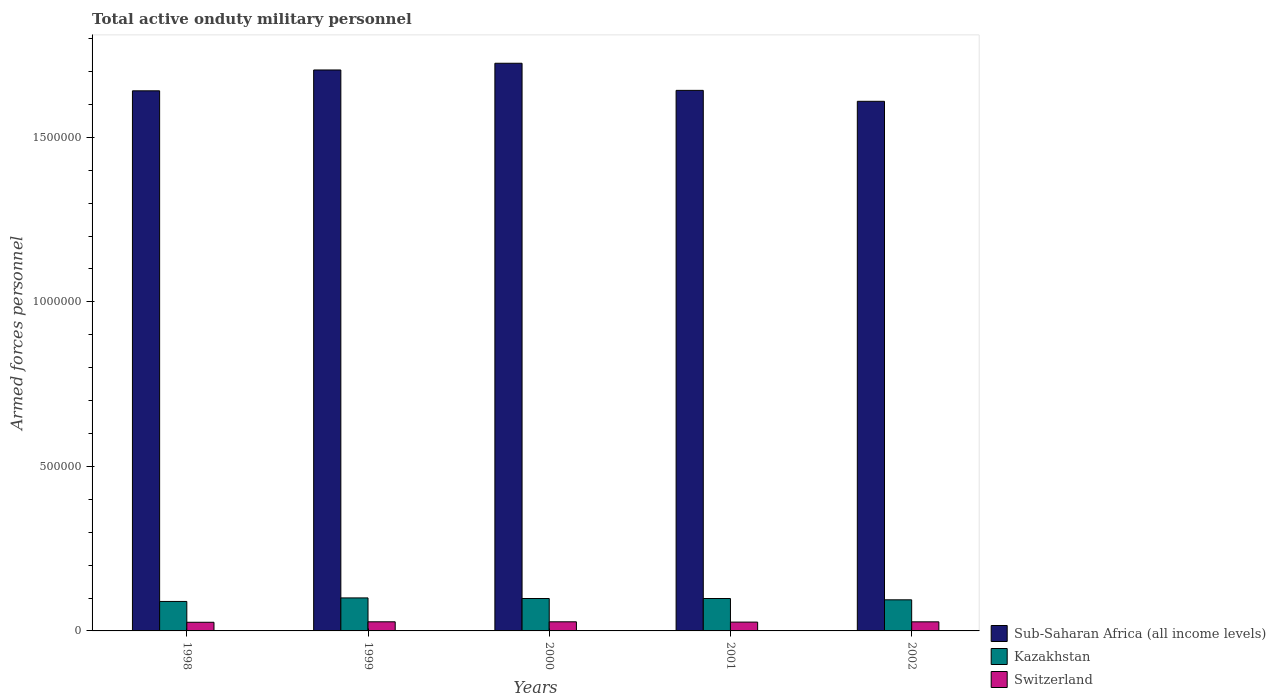How many different coloured bars are there?
Make the answer very short. 3. How many groups of bars are there?
Provide a short and direct response. 5. Are the number of bars on each tick of the X-axis equal?
Offer a very short reply. Yes. What is the label of the 2nd group of bars from the left?
Your answer should be very brief. 1999. In how many cases, is the number of bars for a given year not equal to the number of legend labels?
Ensure brevity in your answer.  0. What is the number of armed forces personnel in Kazakhstan in 1999?
Your answer should be very brief. 1.00e+05. Across all years, what is the maximum number of armed forces personnel in Kazakhstan?
Ensure brevity in your answer.  1.00e+05. Across all years, what is the minimum number of armed forces personnel in Switzerland?
Provide a succinct answer. 2.63e+04. What is the total number of armed forces personnel in Switzerland in the graph?
Offer a very short reply. 1.36e+05. What is the difference between the number of armed forces personnel in Sub-Saharan Africa (all income levels) in 1998 and that in 2001?
Offer a terse response. -1350. What is the difference between the number of armed forces personnel in Kazakhstan in 1998 and the number of armed forces personnel in Switzerland in 2002?
Offer a very short reply. 6.20e+04. What is the average number of armed forces personnel in Switzerland per year?
Provide a succinct answer. 2.72e+04. In the year 1998, what is the difference between the number of armed forces personnel in Sub-Saharan Africa (all income levels) and number of armed forces personnel in Switzerland?
Offer a very short reply. 1.62e+06. In how many years, is the number of armed forces personnel in Sub-Saharan Africa (all income levels) greater than 400000?
Your answer should be very brief. 5. What is the ratio of the number of armed forces personnel in Switzerland in 1999 to that in 2000?
Keep it short and to the point. 1. Is the number of armed forces personnel in Kazakhstan in 2000 less than that in 2002?
Keep it short and to the point. No. What is the difference between the highest and the second highest number of armed forces personnel in Sub-Saharan Africa (all income levels)?
Keep it short and to the point. 2.04e+04. What is the difference between the highest and the lowest number of armed forces personnel in Kazakhstan?
Keep it short and to the point. 1.07e+04. What does the 3rd bar from the left in 1998 represents?
Your response must be concise. Switzerland. What does the 3rd bar from the right in 2001 represents?
Your response must be concise. Sub-Saharan Africa (all income levels). Are all the bars in the graph horizontal?
Keep it short and to the point. No. How many years are there in the graph?
Ensure brevity in your answer.  5. What is the difference between two consecutive major ticks on the Y-axis?
Provide a short and direct response. 5.00e+05. Are the values on the major ticks of Y-axis written in scientific E-notation?
Make the answer very short. No. Does the graph contain any zero values?
Provide a succinct answer. No. Where does the legend appear in the graph?
Offer a very short reply. Bottom right. How many legend labels are there?
Keep it short and to the point. 3. What is the title of the graph?
Keep it short and to the point. Total active onduty military personnel. What is the label or title of the Y-axis?
Give a very brief answer. Armed forces personnel. What is the Armed forces personnel in Sub-Saharan Africa (all income levels) in 1998?
Make the answer very short. 1.64e+06. What is the Armed forces personnel of Kazakhstan in 1998?
Your answer should be very brief. 8.96e+04. What is the Armed forces personnel of Switzerland in 1998?
Keep it short and to the point. 2.63e+04. What is the Armed forces personnel of Sub-Saharan Africa (all income levels) in 1999?
Provide a short and direct response. 1.70e+06. What is the Armed forces personnel in Kazakhstan in 1999?
Offer a very short reply. 1.00e+05. What is the Armed forces personnel in Switzerland in 1999?
Offer a terse response. 2.77e+04. What is the Armed forces personnel of Sub-Saharan Africa (all income levels) in 2000?
Your answer should be compact. 1.73e+06. What is the Armed forces personnel in Kazakhstan in 2000?
Your answer should be very brief. 9.85e+04. What is the Armed forces personnel of Switzerland in 2000?
Give a very brief answer. 2.77e+04. What is the Armed forces personnel of Sub-Saharan Africa (all income levels) in 2001?
Provide a succinct answer. 1.64e+06. What is the Armed forces personnel in Kazakhstan in 2001?
Offer a very short reply. 9.85e+04. What is the Armed forces personnel of Switzerland in 2001?
Offer a very short reply. 2.68e+04. What is the Armed forces personnel of Sub-Saharan Africa (all income levels) in 2002?
Provide a succinct answer. 1.61e+06. What is the Armed forces personnel in Kazakhstan in 2002?
Give a very brief answer. 9.45e+04. What is the Armed forces personnel of Switzerland in 2002?
Offer a terse response. 2.76e+04. Across all years, what is the maximum Armed forces personnel of Sub-Saharan Africa (all income levels)?
Offer a terse response. 1.73e+06. Across all years, what is the maximum Armed forces personnel in Kazakhstan?
Offer a terse response. 1.00e+05. Across all years, what is the maximum Armed forces personnel of Switzerland?
Your answer should be compact. 2.77e+04. Across all years, what is the minimum Armed forces personnel in Sub-Saharan Africa (all income levels)?
Provide a short and direct response. 1.61e+06. Across all years, what is the minimum Armed forces personnel of Kazakhstan?
Provide a succinct answer. 8.96e+04. Across all years, what is the minimum Armed forces personnel in Switzerland?
Provide a succinct answer. 2.63e+04. What is the total Armed forces personnel of Sub-Saharan Africa (all income levels) in the graph?
Provide a succinct answer. 8.32e+06. What is the total Armed forces personnel in Kazakhstan in the graph?
Make the answer very short. 4.81e+05. What is the total Armed forces personnel in Switzerland in the graph?
Ensure brevity in your answer.  1.36e+05. What is the difference between the Armed forces personnel of Sub-Saharan Africa (all income levels) in 1998 and that in 1999?
Your answer should be compact. -6.34e+04. What is the difference between the Armed forces personnel of Kazakhstan in 1998 and that in 1999?
Offer a very short reply. -1.07e+04. What is the difference between the Armed forces personnel in Switzerland in 1998 and that in 1999?
Provide a short and direct response. -1400. What is the difference between the Armed forces personnel in Sub-Saharan Africa (all income levels) in 1998 and that in 2000?
Make the answer very short. -8.38e+04. What is the difference between the Armed forces personnel in Kazakhstan in 1998 and that in 2000?
Offer a terse response. -8900. What is the difference between the Armed forces personnel in Switzerland in 1998 and that in 2000?
Your answer should be very brief. -1400. What is the difference between the Armed forces personnel in Sub-Saharan Africa (all income levels) in 1998 and that in 2001?
Make the answer very short. -1350. What is the difference between the Armed forces personnel of Kazakhstan in 1998 and that in 2001?
Offer a very short reply. -8900. What is the difference between the Armed forces personnel in Switzerland in 1998 and that in 2001?
Provide a short and direct response. -500. What is the difference between the Armed forces personnel in Sub-Saharan Africa (all income levels) in 1998 and that in 2002?
Provide a short and direct response. 3.19e+04. What is the difference between the Armed forces personnel of Kazakhstan in 1998 and that in 2002?
Ensure brevity in your answer.  -4900. What is the difference between the Armed forces personnel in Switzerland in 1998 and that in 2002?
Offer a very short reply. -1300. What is the difference between the Armed forces personnel of Sub-Saharan Africa (all income levels) in 1999 and that in 2000?
Offer a very short reply. -2.04e+04. What is the difference between the Armed forces personnel of Kazakhstan in 1999 and that in 2000?
Provide a succinct answer. 1800. What is the difference between the Armed forces personnel of Sub-Saharan Africa (all income levels) in 1999 and that in 2001?
Ensure brevity in your answer.  6.20e+04. What is the difference between the Armed forces personnel of Kazakhstan in 1999 and that in 2001?
Make the answer very short. 1800. What is the difference between the Armed forces personnel of Switzerland in 1999 and that in 2001?
Provide a succinct answer. 900. What is the difference between the Armed forces personnel in Sub-Saharan Africa (all income levels) in 1999 and that in 2002?
Make the answer very short. 9.52e+04. What is the difference between the Armed forces personnel in Kazakhstan in 1999 and that in 2002?
Ensure brevity in your answer.  5800. What is the difference between the Armed forces personnel in Sub-Saharan Africa (all income levels) in 2000 and that in 2001?
Offer a terse response. 8.24e+04. What is the difference between the Armed forces personnel in Kazakhstan in 2000 and that in 2001?
Make the answer very short. 0. What is the difference between the Armed forces personnel of Switzerland in 2000 and that in 2001?
Your answer should be very brief. 900. What is the difference between the Armed forces personnel in Sub-Saharan Africa (all income levels) in 2000 and that in 2002?
Provide a short and direct response. 1.16e+05. What is the difference between the Armed forces personnel in Kazakhstan in 2000 and that in 2002?
Provide a short and direct response. 4000. What is the difference between the Armed forces personnel of Sub-Saharan Africa (all income levels) in 2001 and that in 2002?
Your response must be concise. 3.32e+04. What is the difference between the Armed forces personnel of Kazakhstan in 2001 and that in 2002?
Give a very brief answer. 4000. What is the difference between the Armed forces personnel in Switzerland in 2001 and that in 2002?
Your response must be concise. -800. What is the difference between the Armed forces personnel of Sub-Saharan Africa (all income levels) in 1998 and the Armed forces personnel of Kazakhstan in 1999?
Your response must be concise. 1.54e+06. What is the difference between the Armed forces personnel in Sub-Saharan Africa (all income levels) in 1998 and the Armed forces personnel in Switzerland in 1999?
Offer a very short reply. 1.61e+06. What is the difference between the Armed forces personnel in Kazakhstan in 1998 and the Armed forces personnel in Switzerland in 1999?
Your answer should be very brief. 6.19e+04. What is the difference between the Armed forces personnel in Sub-Saharan Africa (all income levels) in 1998 and the Armed forces personnel in Kazakhstan in 2000?
Ensure brevity in your answer.  1.54e+06. What is the difference between the Armed forces personnel of Sub-Saharan Africa (all income levels) in 1998 and the Armed forces personnel of Switzerland in 2000?
Keep it short and to the point. 1.61e+06. What is the difference between the Armed forces personnel of Kazakhstan in 1998 and the Armed forces personnel of Switzerland in 2000?
Your response must be concise. 6.19e+04. What is the difference between the Armed forces personnel of Sub-Saharan Africa (all income levels) in 1998 and the Armed forces personnel of Kazakhstan in 2001?
Keep it short and to the point. 1.54e+06. What is the difference between the Armed forces personnel of Sub-Saharan Africa (all income levels) in 1998 and the Armed forces personnel of Switzerland in 2001?
Provide a succinct answer. 1.61e+06. What is the difference between the Armed forces personnel in Kazakhstan in 1998 and the Armed forces personnel in Switzerland in 2001?
Offer a very short reply. 6.28e+04. What is the difference between the Armed forces personnel of Sub-Saharan Africa (all income levels) in 1998 and the Armed forces personnel of Kazakhstan in 2002?
Ensure brevity in your answer.  1.55e+06. What is the difference between the Armed forces personnel in Sub-Saharan Africa (all income levels) in 1998 and the Armed forces personnel in Switzerland in 2002?
Provide a succinct answer. 1.61e+06. What is the difference between the Armed forces personnel in Kazakhstan in 1998 and the Armed forces personnel in Switzerland in 2002?
Your answer should be very brief. 6.20e+04. What is the difference between the Armed forces personnel in Sub-Saharan Africa (all income levels) in 1999 and the Armed forces personnel in Kazakhstan in 2000?
Provide a short and direct response. 1.61e+06. What is the difference between the Armed forces personnel of Sub-Saharan Africa (all income levels) in 1999 and the Armed forces personnel of Switzerland in 2000?
Make the answer very short. 1.68e+06. What is the difference between the Armed forces personnel of Kazakhstan in 1999 and the Armed forces personnel of Switzerland in 2000?
Offer a terse response. 7.26e+04. What is the difference between the Armed forces personnel of Sub-Saharan Africa (all income levels) in 1999 and the Armed forces personnel of Kazakhstan in 2001?
Give a very brief answer. 1.61e+06. What is the difference between the Armed forces personnel in Sub-Saharan Africa (all income levels) in 1999 and the Armed forces personnel in Switzerland in 2001?
Provide a succinct answer. 1.68e+06. What is the difference between the Armed forces personnel of Kazakhstan in 1999 and the Armed forces personnel of Switzerland in 2001?
Offer a very short reply. 7.35e+04. What is the difference between the Armed forces personnel of Sub-Saharan Africa (all income levels) in 1999 and the Armed forces personnel of Kazakhstan in 2002?
Ensure brevity in your answer.  1.61e+06. What is the difference between the Armed forces personnel in Sub-Saharan Africa (all income levels) in 1999 and the Armed forces personnel in Switzerland in 2002?
Your answer should be compact. 1.68e+06. What is the difference between the Armed forces personnel of Kazakhstan in 1999 and the Armed forces personnel of Switzerland in 2002?
Your answer should be very brief. 7.27e+04. What is the difference between the Armed forces personnel in Sub-Saharan Africa (all income levels) in 2000 and the Armed forces personnel in Kazakhstan in 2001?
Your answer should be compact. 1.63e+06. What is the difference between the Armed forces personnel in Sub-Saharan Africa (all income levels) in 2000 and the Armed forces personnel in Switzerland in 2001?
Offer a terse response. 1.70e+06. What is the difference between the Armed forces personnel in Kazakhstan in 2000 and the Armed forces personnel in Switzerland in 2001?
Your response must be concise. 7.17e+04. What is the difference between the Armed forces personnel of Sub-Saharan Africa (all income levels) in 2000 and the Armed forces personnel of Kazakhstan in 2002?
Provide a short and direct response. 1.63e+06. What is the difference between the Armed forces personnel of Sub-Saharan Africa (all income levels) in 2000 and the Armed forces personnel of Switzerland in 2002?
Provide a short and direct response. 1.70e+06. What is the difference between the Armed forces personnel in Kazakhstan in 2000 and the Armed forces personnel in Switzerland in 2002?
Your answer should be very brief. 7.09e+04. What is the difference between the Armed forces personnel in Sub-Saharan Africa (all income levels) in 2001 and the Armed forces personnel in Kazakhstan in 2002?
Your answer should be very brief. 1.55e+06. What is the difference between the Armed forces personnel in Sub-Saharan Africa (all income levels) in 2001 and the Armed forces personnel in Switzerland in 2002?
Provide a short and direct response. 1.62e+06. What is the difference between the Armed forces personnel of Kazakhstan in 2001 and the Armed forces personnel of Switzerland in 2002?
Your answer should be compact. 7.09e+04. What is the average Armed forces personnel in Sub-Saharan Africa (all income levels) per year?
Ensure brevity in your answer.  1.66e+06. What is the average Armed forces personnel in Kazakhstan per year?
Keep it short and to the point. 9.63e+04. What is the average Armed forces personnel in Switzerland per year?
Keep it short and to the point. 2.72e+04. In the year 1998, what is the difference between the Armed forces personnel in Sub-Saharan Africa (all income levels) and Armed forces personnel in Kazakhstan?
Provide a short and direct response. 1.55e+06. In the year 1998, what is the difference between the Armed forces personnel of Sub-Saharan Africa (all income levels) and Armed forces personnel of Switzerland?
Your answer should be compact. 1.62e+06. In the year 1998, what is the difference between the Armed forces personnel of Kazakhstan and Armed forces personnel of Switzerland?
Provide a short and direct response. 6.33e+04. In the year 1999, what is the difference between the Armed forces personnel in Sub-Saharan Africa (all income levels) and Armed forces personnel in Kazakhstan?
Keep it short and to the point. 1.60e+06. In the year 1999, what is the difference between the Armed forces personnel of Sub-Saharan Africa (all income levels) and Armed forces personnel of Switzerland?
Your answer should be very brief. 1.68e+06. In the year 1999, what is the difference between the Armed forces personnel of Kazakhstan and Armed forces personnel of Switzerland?
Ensure brevity in your answer.  7.26e+04. In the year 2000, what is the difference between the Armed forces personnel in Sub-Saharan Africa (all income levels) and Armed forces personnel in Kazakhstan?
Ensure brevity in your answer.  1.63e+06. In the year 2000, what is the difference between the Armed forces personnel in Sub-Saharan Africa (all income levels) and Armed forces personnel in Switzerland?
Keep it short and to the point. 1.70e+06. In the year 2000, what is the difference between the Armed forces personnel in Kazakhstan and Armed forces personnel in Switzerland?
Your answer should be compact. 7.08e+04. In the year 2001, what is the difference between the Armed forces personnel of Sub-Saharan Africa (all income levels) and Armed forces personnel of Kazakhstan?
Provide a succinct answer. 1.54e+06. In the year 2001, what is the difference between the Armed forces personnel of Sub-Saharan Africa (all income levels) and Armed forces personnel of Switzerland?
Provide a succinct answer. 1.62e+06. In the year 2001, what is the difference between the Armed forces personnel in Kazakhstan and Armed forces personnel in Switzerland?
Your answer should be very brief. 7.17e+04. In the year 2002, what is the difference between the Armed forces personnel in Sub-Saharan Africa (all income levels) and Armed forces personnel in Kazakhstan?
Give a very brief answer. 1.52e+06. In the year 2002, what is the difference between the Armed forces personnel in Sub-Saharan Africa (all income levels) and Armed forces personnel in Switzerland?
Keep it short and to the point. 1.58e+06. In the year 2002, what is the difference between the Armed forces personnel of Kazakhstan and Armed forces personnel of Switzerland?
Your response must be concise. 6.69e+04. What is the ratio of the Armed forces personnel of Sub-Saharan Africa (all income levels) in 1998 to that in 1999?
Make the answer very short. 0.96. What is the ratio of the Armed forces personnel in Kazakhstan in 1998 to that in 1999?
Give a very brief answer. 0.89. What is the ratio of the Armed forces personnel in Switzerland in 1998 to that in 1999?
Keep it short and to the point. 0.95. What is the ratio of the Armed forces personnel of Sub-Saharan Africa (all income levels) in 1998 to that in 2000?
Your answer should be very brief. 0.95. What is the ratio of the Armed forces personnel in Kazakhstan in 1998 to that in 2000?
Your answer should be very brief. 0.91. What is the ratio of the Armed forces personnel of Switzerland in 1998 to that in 2000?
Provide a succinct answer. 0.95. What is the ratio of the Armed forces personnel in Kazakhstan in 1998 to that in 2001?
Offer a very short reply. 0.91. What is the ratio of the Armed forces personnel in Switzerland in 1998 to that in 2001?
Your answer should be compact. 0.98. What is the ratio of the Armed forces personnel of Sub-Saharan Africa (all income levels) in 1998 to that in 2002?
Give a very brief answer. 1.02. What is the ratio of the Armed forces personnel of Kazakhstan in 1998 to that in 2002?
Offer a terse response. 0.95. What is the ratio of the Armed forces personnel in Switzerland in 1998 to that in 2002?
Your response must be concise. 0.95. What is the ratio of the Armed forces personnel in Sub-Saharan Africa (all income levels) in 1999 to that in 2000?
Keep it short and to the point. 0.99. What is the ratio of the Armed forces personnel of Kazakhstan in 1999 to that in 2000?
Offer a terse response. 1.02. What is the ratio of the Armed forces personnel in Sub-Saharan Africa (all income levels) in 1999 to that in 2001?
Ensure brevity in your answer.  1.04. What is the ratio of the Armed forces personnel of Kazakhstan in 1999 to that in 2001?
Provide a short and direct response. 1.02. What is the ratio of the Armed forces personnel of Switzerland in 1999 to that in 2001?
Your answer should be very brief. 1.03. What is the ratio of the Armed forces personnel in Sub-Saharan Africa (all income levels) in 1999 to that in 2002?
Give a very brief answer. 1.06. What is the ratio of the Armed forces personnel in Kazakhstan in 1999 to that in 2002?
Offer a very short reply. 1.06. What is the ratio of the Armed forces personnel in Switzerland in 1999 to that in 2002?
Give a very brief answer. 1. What is the ratio of the Armed forces personnel of Sub-Saharan Africa (all income levels) in 2000 to that in 2001?
Provide a succinct answer. 1.05. What is the ratio of the Armed forces personnel of Switzerland in 2000 to that in 2001?
Your response must be concise. 1.03. What is the ratio of the Armed forces personnel of Sub-Saharan Africa (all income levels) in 2000 to that in 2002?
Your response must be concise. 1.07. What is the ratio of the Armed forces personnel of Kazakhstan in 2000 to that in 2002?
Offer a very short reply. 1.04. What is the ratio of the Armed forces personnel in Sub-Saharan Africa (all income levels) in 2001 to that in 2002?
Keep it short and to the point. 1.02. What is the ratio of the Armed forces personnel in Kazakhstan in 2001 to that in 2002?
Keep it short and to the point. 1.04. What is the difference between the highest and the second highest Armed forces personnel in Sub-Saharan Africa (all income levels)?
Your response must be concise. 2.04e+04. What is the difference between the highest and the second highest Armed forces personnel of Kazakhstan?
Make the answer very short. 1800. What is the difference between the highest and the lowest Armed forces personnel in Sub-Saharan Africa (all income levels)?
Your answer should be compact. 1.16e+05. What is the difference between the highest and the lowest Armed forces personnel in Kazakhstan?
Your answer should be very brief. 1.07e+04. What is the difference between the highest and the lowest Armed forces personnel in Switzerland?
Provide a succinct answer. 1400. 